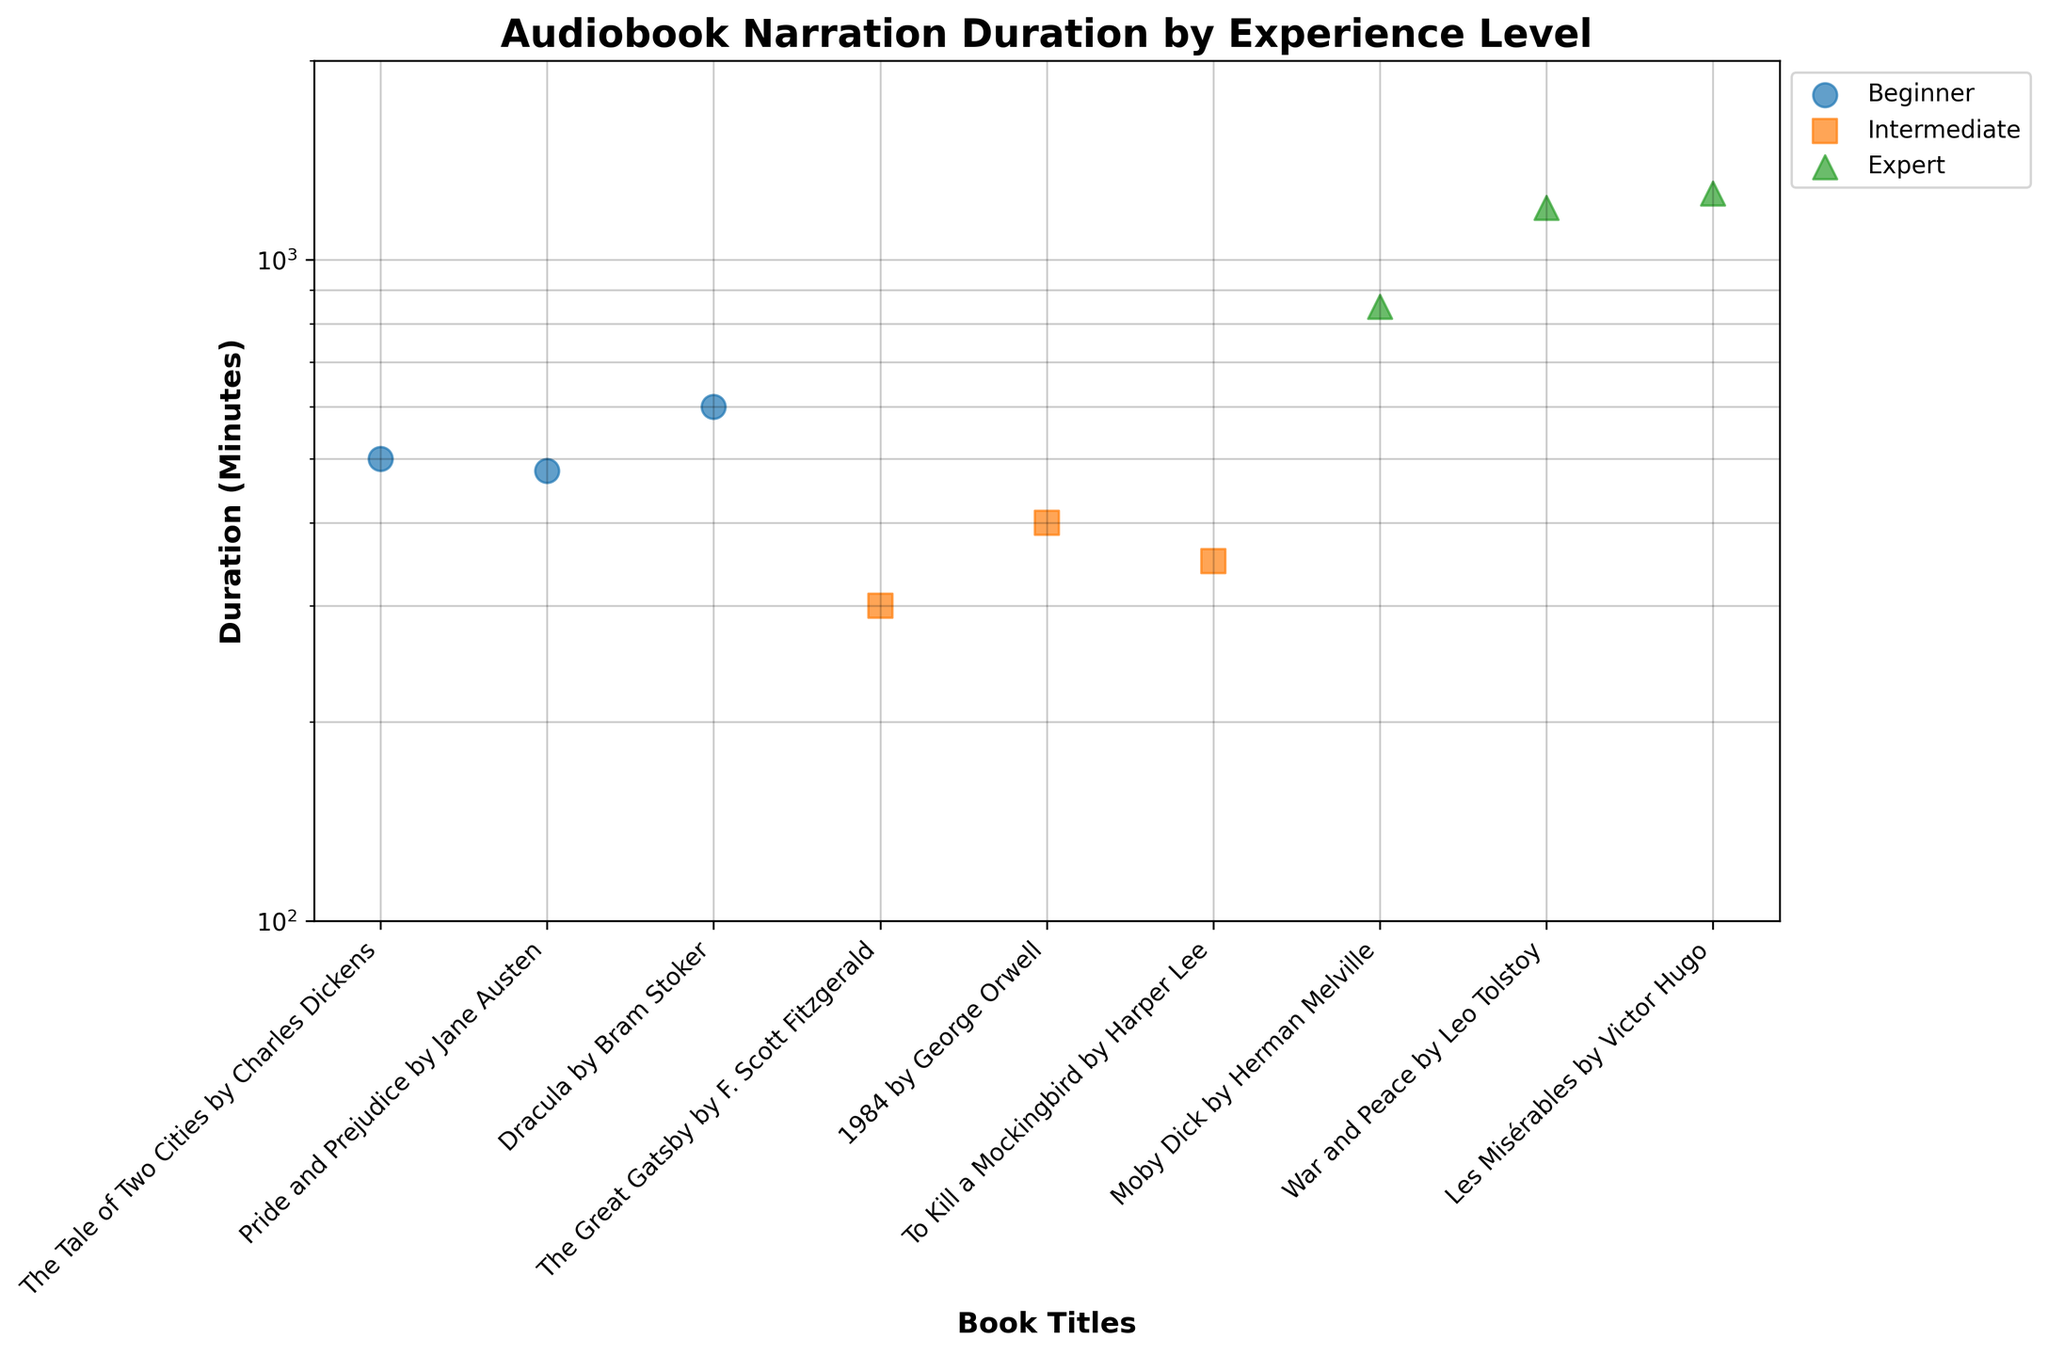What is the title of the plot? The title of the plot is prominently displayed at the top center of the figure. It reads "Audiobook Narration Duration by Experience Level".
Answer: Audiobook Narration Duration by Experience Level What is the y-axis scale on the plot? By examining the axis labels and the distribution of data points, it is clear that the y-axis is logarithmic. This is indicated by the uneven spacing of the tick marks and the significant difference between the minimum and maximum values, ranging from 100 to 2000.
Answer: Logarithmic Which experience level has the longest audiobook narration duration? Observing the figure, I can see that the data points for "Expert" are the highest on the y-axis. The longest duration for an "Expert" is the point at "War and Peace" by Leo Tolstoy, which is around 1200 minutes.
Answer: Expert How does the duration of "Dracula" by Bram Stoker compare with other "Beginner" titles? In the figure, "Dracula" by Bram Stoker (600 minutes) is compared to "The Tale of Two Cities" by Charles Dickens (500 minutes) and "Pride and Prejudice" by Jane Austen (480 minutes). "Dracula" has a longer duration than the other two "Beginner" titles.
Answer: "Dracula" is longer What is the average duration of audiobooks narrated by Intermediate level narrators? There are three Intermediate titles: "The Great Gatsby" (300 minutes), "1984" (400 minutes), and "To Kill a Mockingbird" (350 minutes). To find the average duration, sum these values and divide by the number of audiobooks. (300 + 400 + 350) / 3 = 1050 / 3 = 350
Answer: 350 Which book title has the shortest narration duration, and what is its experience level? By examining the lowest data points, the shortest duration is for "The Great Gatsby" by F. Scott Fitzgerald at 300 minutes, which falls under the "Intermediate" experience level.
Answer: "The Great Gatsby", Intermediate What is the range of audiobook durations for the "Expert" experience level? "Expert" titles have durations ranging from "Moby Dick" by Herman Melville at 850 minutes to "Les Misérables" by Victor Hugo at 1260 minutes. The range is determined by subtracting the smallest value from the largest. 1260 - 850 = 410
Answer: 410 How do the durations of "Beginner" titles compare with "Intermediate" titles? "Beginner" titles range from 480 to 600 minutes, while "Intermediate" titles range from 300 to 400 minutes. Overall, "Beginner" titles have higher durations on average compared to "Intermediate".
Answer: "Beginner" typically higher Which "Expert" title has the highest narration duration, and what is the exact duration? The data point for "Les Misérables" by Victor Hugo is at the highest position in the "Expert" category, with an exact duration of 1260 minutes.
Answer: "Les Misérables", 1260 minutes How many titles fall into the "Intermediate" experience level category? By counting the points labeled under the "Intermediate" legend in the figure, there are three titles in this category: "The Great Gatsby", "1984", and "To Kill a Mockingbird".
Answer: Three 